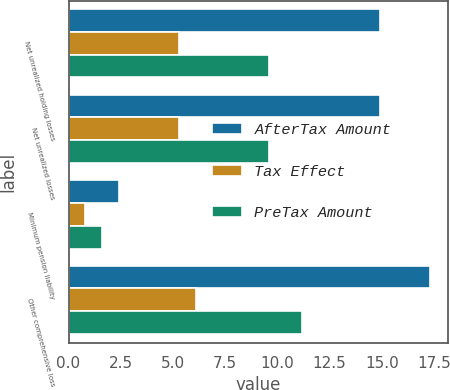<chart> <loc_0><loc_0><loc_500><loc_500><stacked_bar_chart><ecel><fcel>Net unrealized holding losses<fcel>Net unrealized losses<fcel>Minimum pension liability<fcel>Other comprehensive loss<nl><fcel>AfterTax Amount<fcel>14.9<fcel>14.9<fcel>2.4<fcel>17.3<nl><fcel>Tax Effect<fcel>5.3<fcel>5.3<fcel>0.8<fcel>6.1<nl><fcel>PreTax Amount<fcel>9.6<fcel>9.6<fcel>1.6<fcel>11.2<nl></chart> 